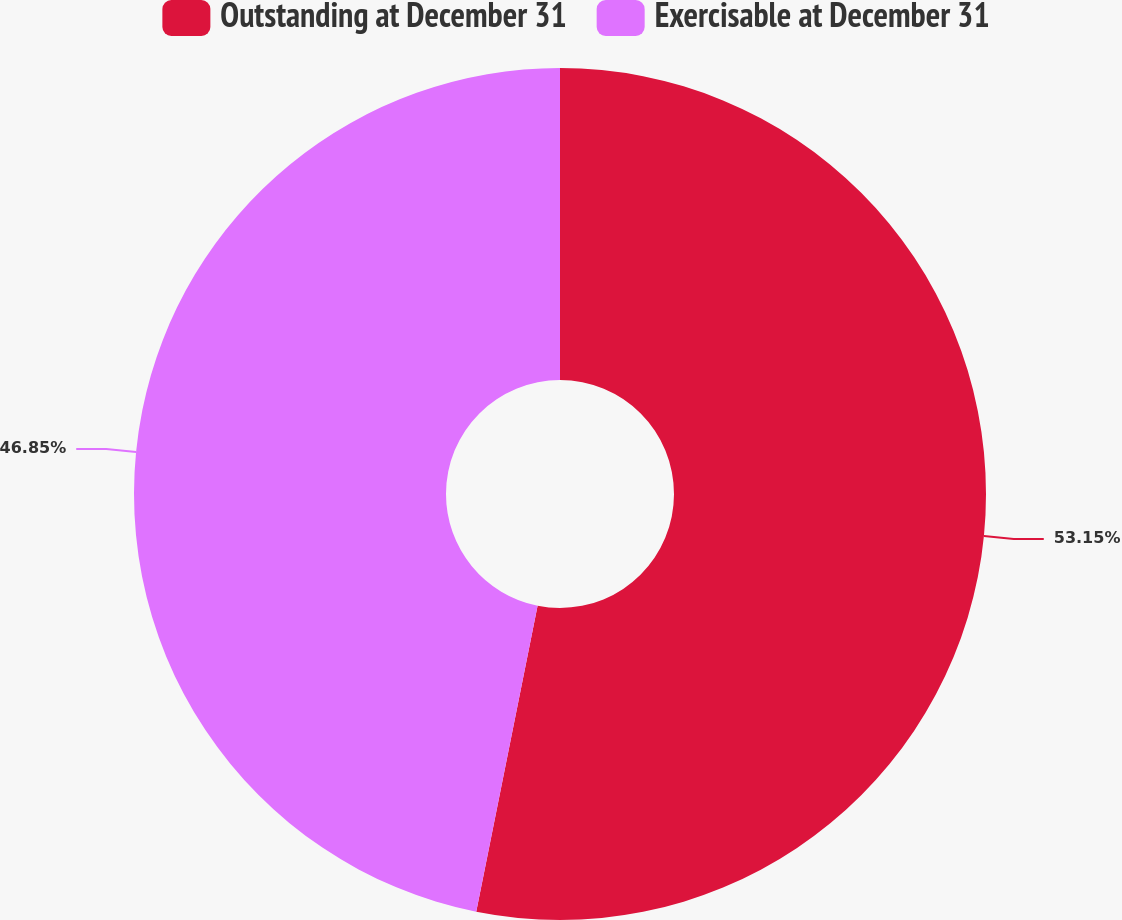Convert chart to OTSL. <chart><loc_0><loc_0><loc_500><loc_500><pie_chart><fcel>Outstanding at December 31<fcel>Exercisable at December 31<nl><fcel>53.15%<fcel>46.85%<nl></chart> 